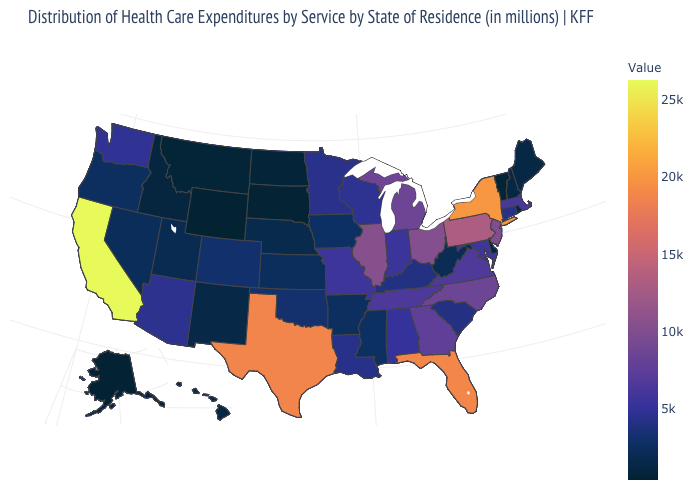Among the states that border Oregon , does Idaho have the lowest value?
Short answer required. Yes. Which states hav the highest value in the MidWest?
Be succinct. Illinois. Does Vermont have the highest value in the Northeast?
Short answer required. No. Among the states that border Minnesota , does Iowa have the lowest value?
Be succinct. No. Which states have the lowest value in the Northeast?
Be succinct. Vermont. Which states have the lowest value in the South?
Quick response, please. Delaware. Which states have the highest value in the USA?
Keep it brief. California. 